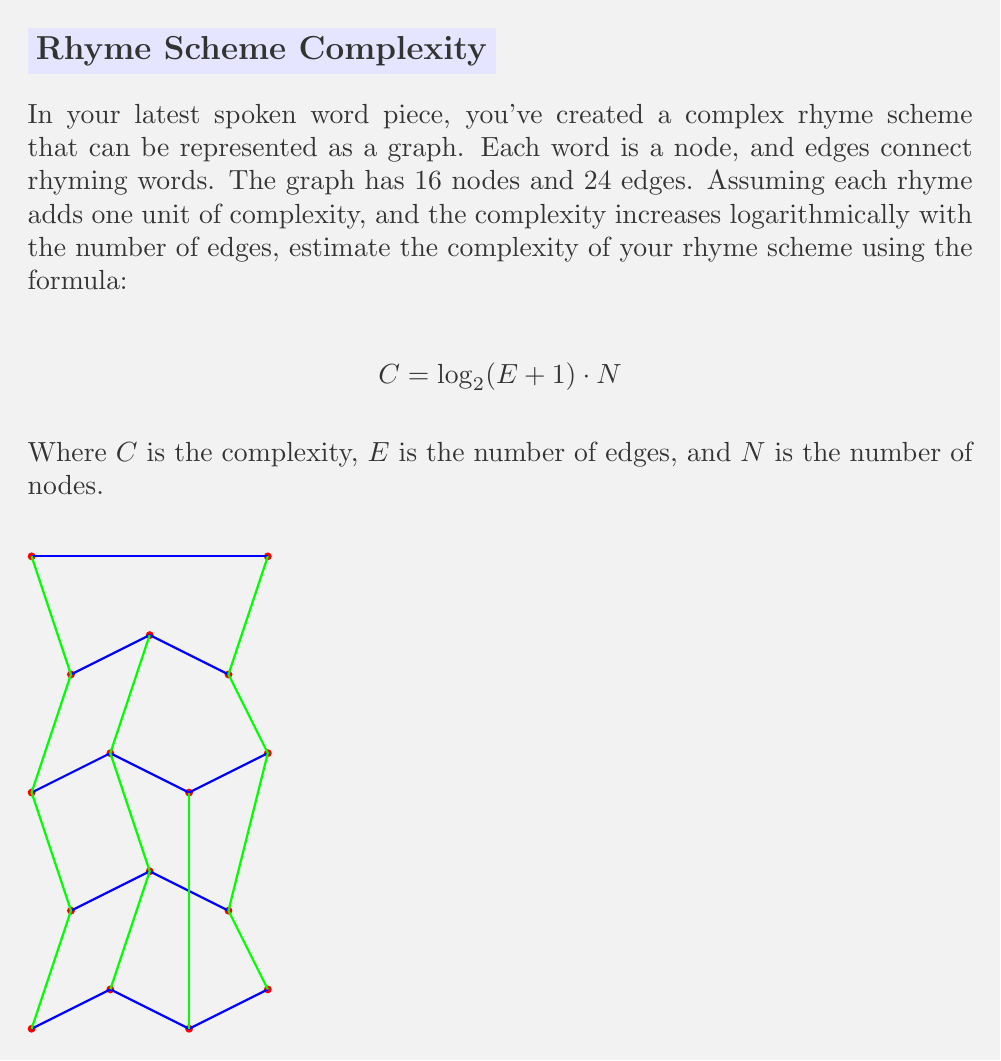Show me your answer to this math problem. Let's approach this step-by-step:

1) We're given that the graph has 16 nodes and 24 edges. So:
   $N = 16$
   $E = 24$

2) We need to use the formula:
   $$C = \log_2(E + 1) \cdot N$$

3) Let's substitute our values:
   $$C = \log_2(24 + 1) \cdot 16$$
   $$C = \log_2(25) \cdot 16$$

4) Now, let's calculate $\log_2(25)$:
   $\log_2(25) \approx 4.64385619$ (rounded to 8 decimal places)

5) Multiply this by 16:
   $C = 4.64385619 \cdot 16 \approx 74.30169904$

6) Rounding to two decimal places for a reasonable estimate:
   $C \approx 74.30$

This value represents the estimated complexity of your rhyme scheme based on the given formula and graph structure.
Answer: $74.30$ 